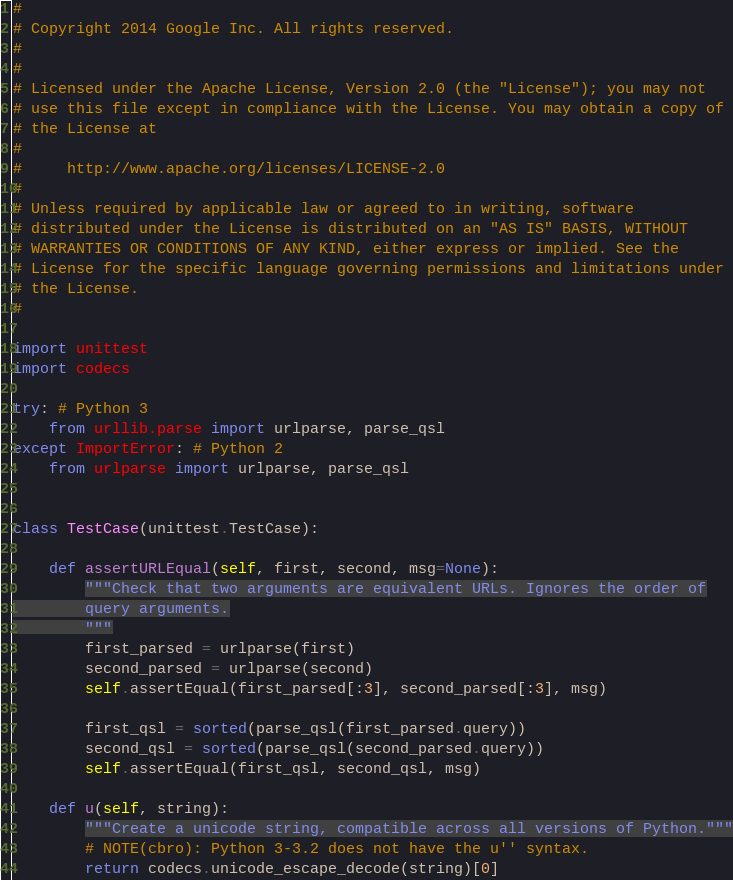Convert code to text. <code><loc_0><loc_0><loc_500><loc_500><_Python_>#
# Copyright 2014 Google Inc. All rights reserved.
#
#
# Licensed under the Apache License, Version 2.0 (the "License"); you may not
# use this file except in compliance with the License. You may obtain a copy of
# the License at
#
#     http://www.apache.org/licenses/LICENSE-2.0
#
# Unless required by applicable law or agreed to in writing, software
# distributed under the License is distributed on an "AS IS" BASIS, WITHOUT
# WARRANTIES OR CONDITIONS OF ANY KIND, either express or implied. See the
# License for the specific language governing permissions and limitations under
# the License.
#

import unittest
import codecs

try: # Python 3
    from urllib.parse import urlparse, parse_qsl
except ImportError: # Python 2
    from urlparse import urlparse, parse_qsl


class TestCase(unittest.TestCase):

    def assertURLEqual(self, first, second, msg=None):
        """Check that two arguments are equivalent URLs. Ignores the order of
        query arguments.
        """
        first_parsed = urlparse(first)
        second_parsed = urlparse(second)
        self.assertEqual(first_parsed[:3], second_parsed[:3], msg)

        first_qsl = sorted(parse_qsl(first_parsed.query))
        second_qsl = sorted(parse_qsl(second_parsed.query))
        self.assertEqual(first_qsl, second_qsl, msg)

    def u(self, string):
        """Create a unicode string, compatible across all versions of Python."""
        # NOTE(cbro): Python 3-3.2 does not have the u'' syntax.
        return codecs.unicode_escape_decode(string)[0]
</code> 